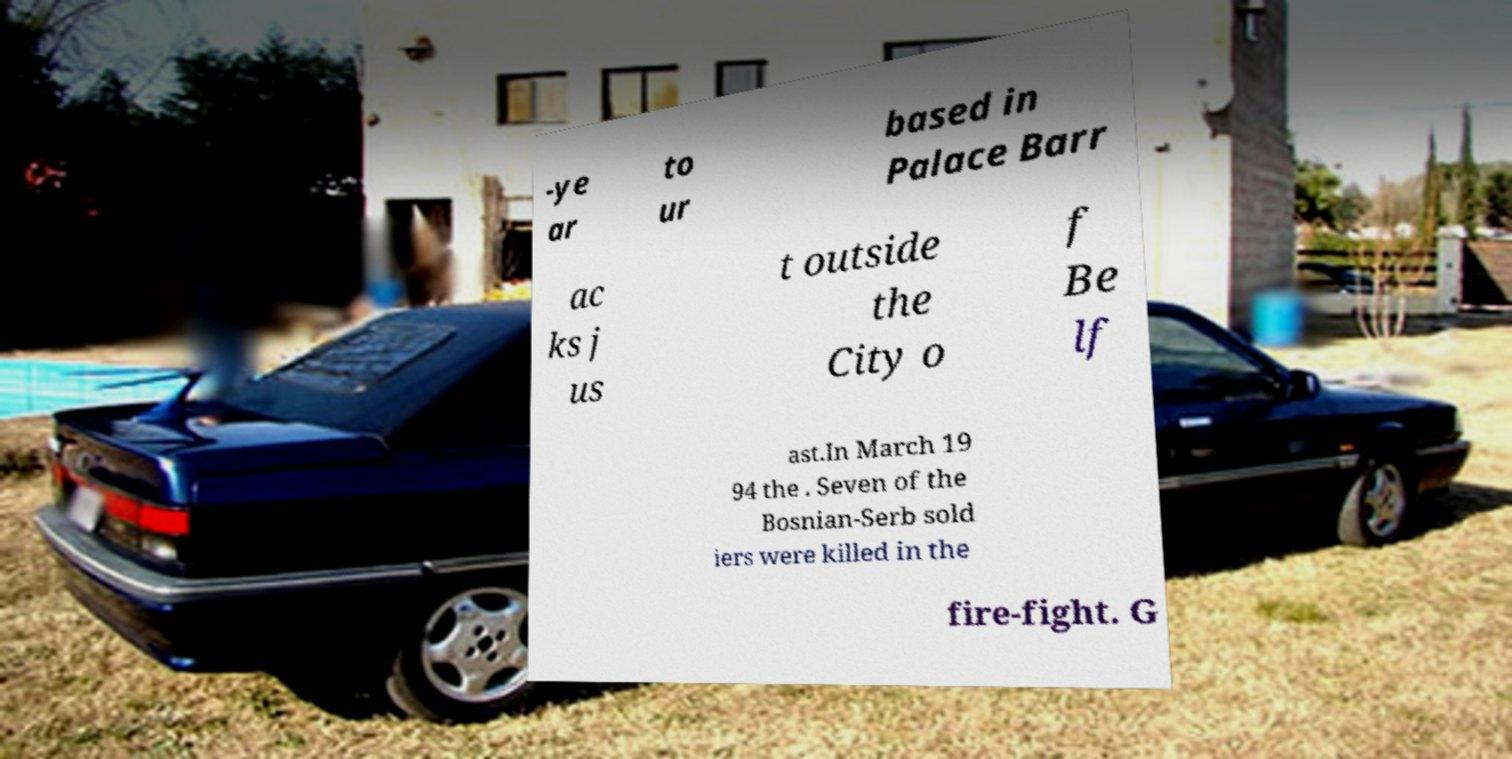Please read and relay the text visible in this image. What does it say? -ye ar to ur based in Palace Barr ac ks j us t outside the City o f Be lf ast.In March 19 94 the . Seven of the Bosnian-Serb sold iers were killed in the fire-fight. G 